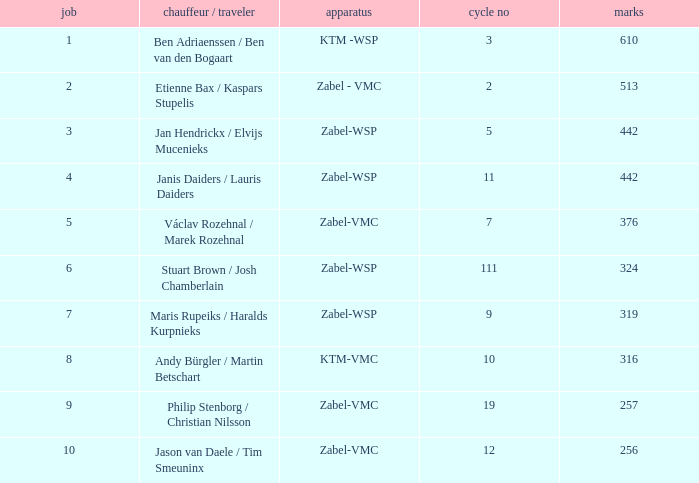What is the most elevated Position that has a Points of 257, and a Bike No littler than 19? None. 